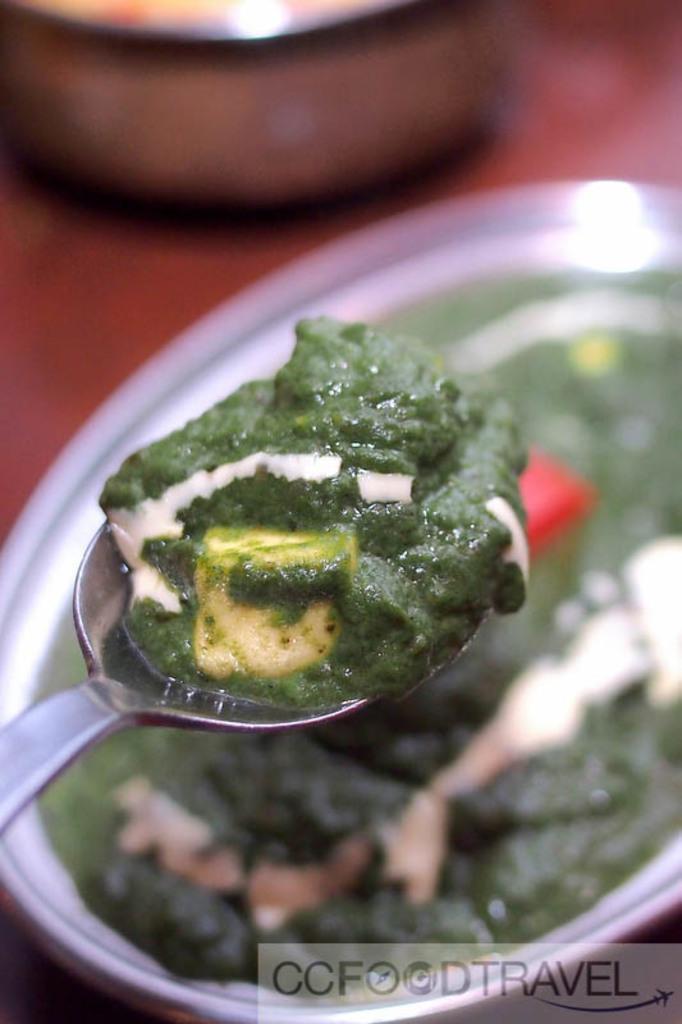How would you summarize this image in a sentence or two? In this image we can see a serving plate with food in it and a spoon. 